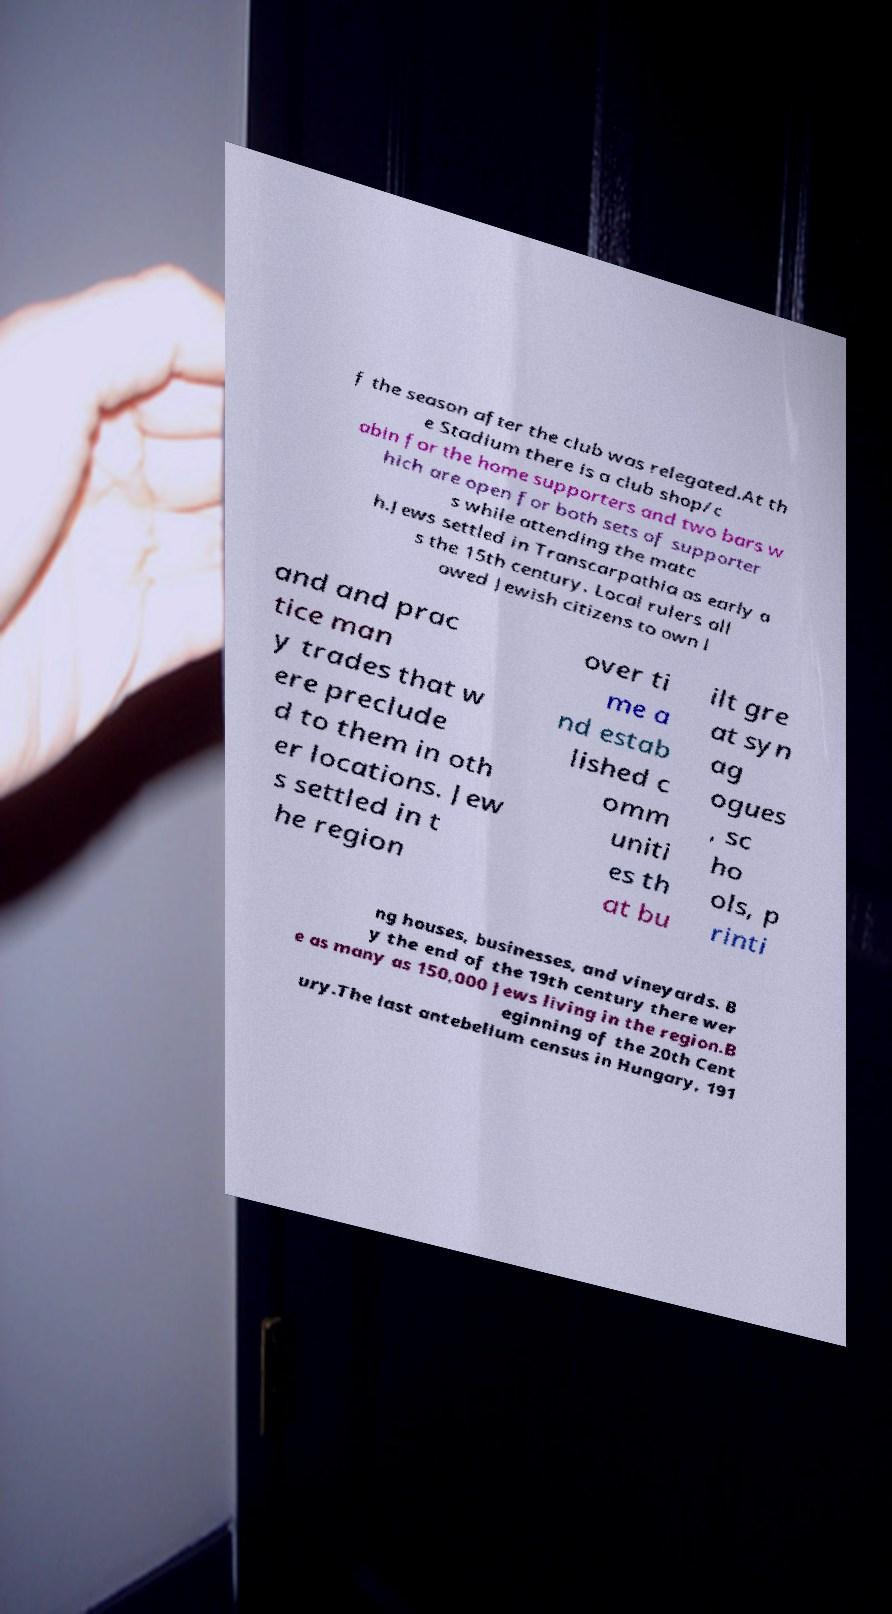Can you read and provide the text displayed in the image?This photo seems to have some interesting text. Can you extract and type it out for me? f the season after the club was relegated.At th e Stadium there is a club shop/c abin for the home supporters and two bars w hich are open for both sets of supporter s while attending the matc h.Jews settled in Transcarpathia as early a s the 15th century. Local rulers all owed Jewish citizens to own l and and prac tice man y trades that w ere preclude d to them in oth er locations. Jew s settled in t he region over ti me a nd estab lished c omm uniti es th at bu ilt gre at syn ag ogues , sc ho ols, p rinti ng houses, businesses, and vineyards. B y the end of the 19th century there wer e as many as 150,000 Jews living in the region.B eginning of the 20th Cent ury.The last antebellum census in Hungary, 191 